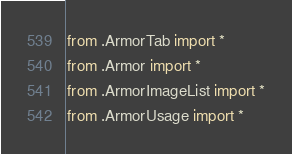Convert code to text. <code><loc_0><loc_0><loc_500><loc_500><_Python_>from .ArmorTab import *
from .Armor import *
from .ArmorImageList import *
from .ArmorUsage import *</code> 